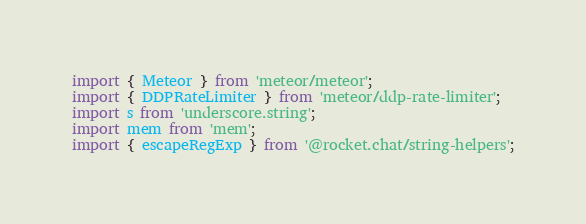Convert code to text. <code><loc_0><loc_0><loc_500><loc_500><_JavaScript_>import { Meteor } from 'meteor/meteor';
import { DDPRateLimiter } from 'meteor/ddp-rate-limiter';
import s from 'underscore.string';
import mem from 'mem';
import { escapeRegExp } from '@rocket.chat/string-helpers';
</code> 